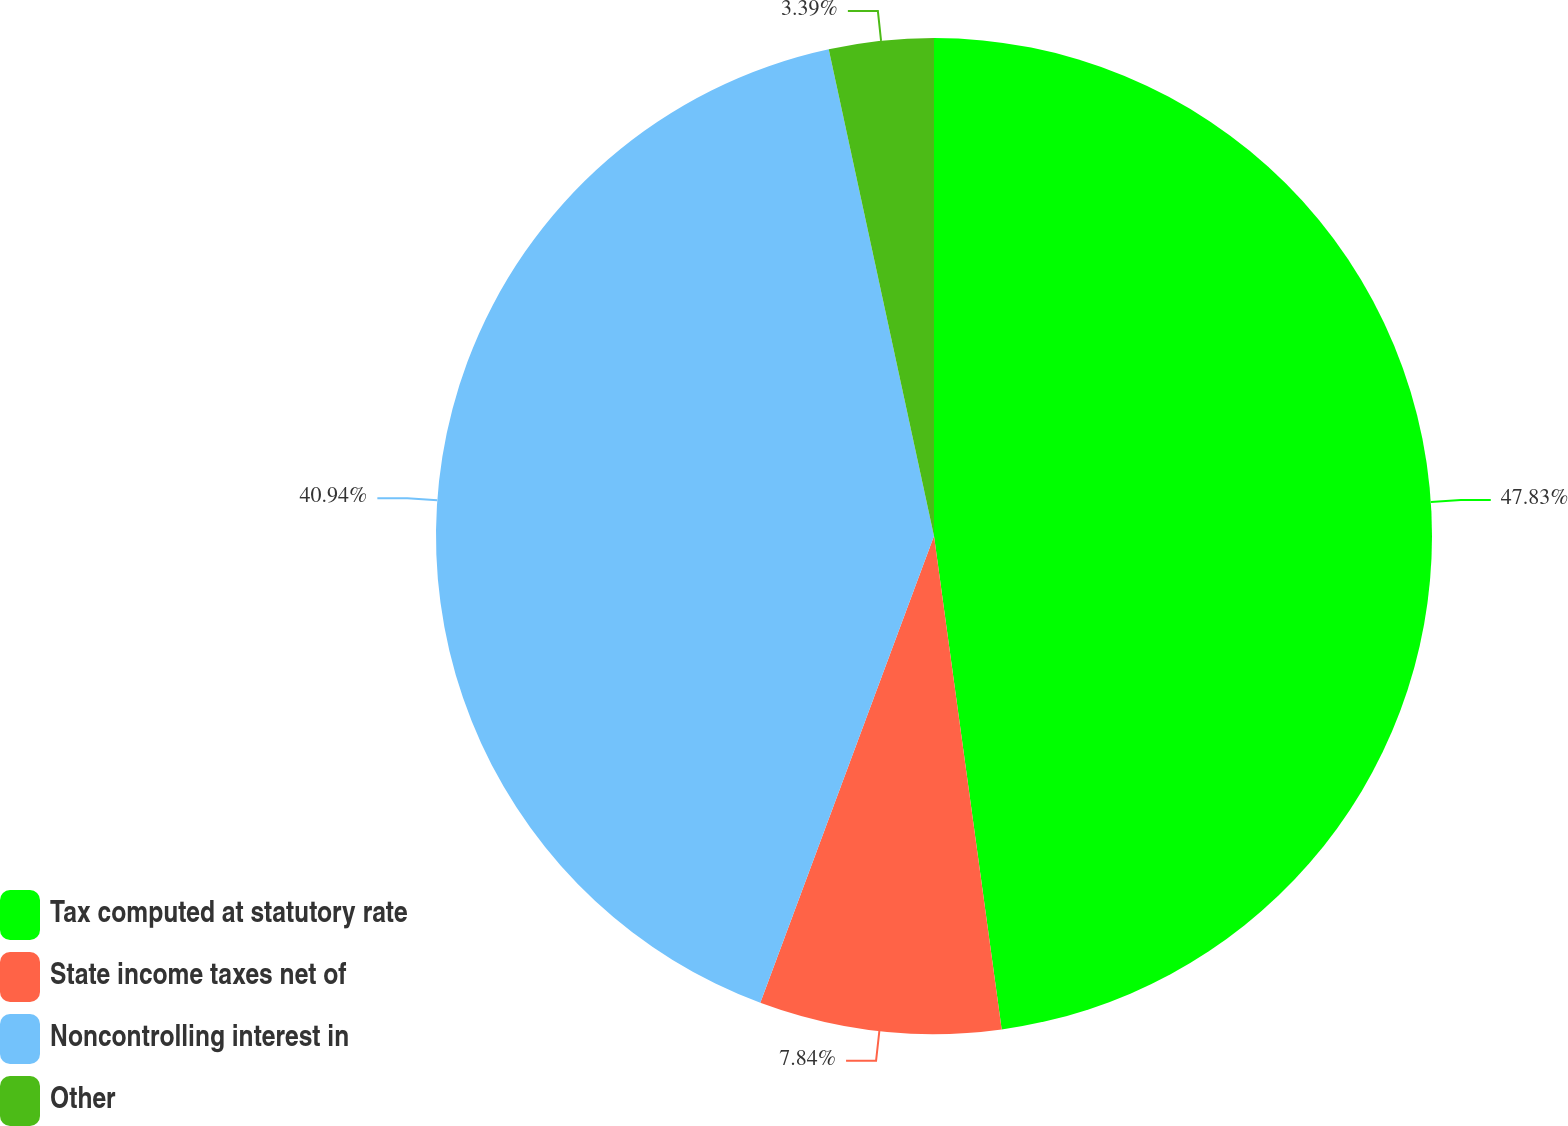Convert chart. <chart><loc_0><loc_0><loc_500><loc_500><pie_chart><fcel>Tax computed at statutory rate<fcel>State income taxes net of<fcel>Noncontrolling interest in<fcel>Other<nl><fcel>47.83%<fcel>7.84%<fcel>40.94%<fcel>3.39%<nl></chart> 